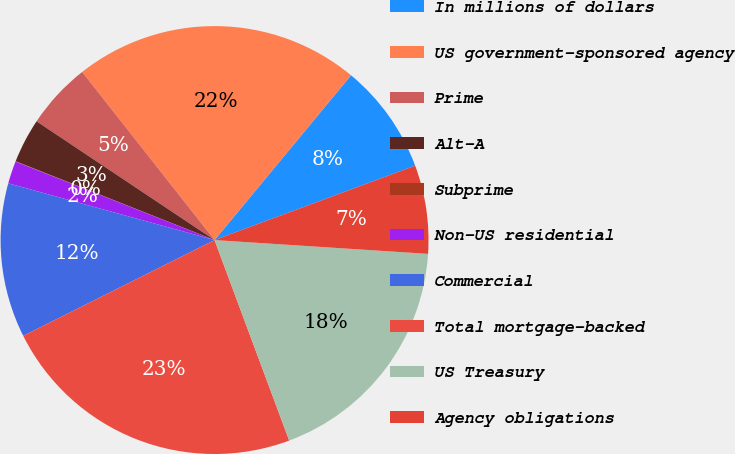Convert chart. <chart><loc_0><loc_0><loc_500><loc_500><pie_chart><fcel>In millions of dollars<fcel>US government-sponsored agency<fcel>Prime<fcel>Alt-A<fcel>Subprime<fcel>Non-US residential<fcel>Commercial<fcel>Total mortgage-backed<fcel>US Treasury<fcel>Agency obligations<nl><fcel>8.34%<fcel>21.63%<fcel>5.02%<fcel>3.36%<fcel>0.03%<fcel>1.7%<fcel>11.66%<fcel>23.29%<fcel>18.3%<fcel>6.68%<nl></chart> 